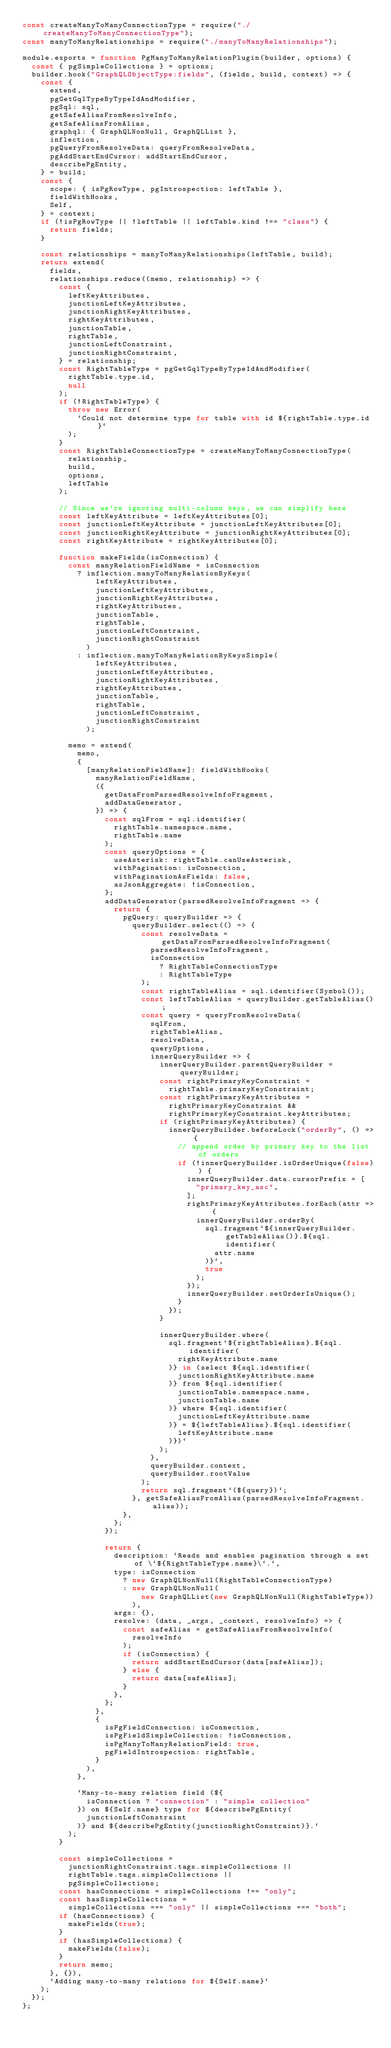<code> <loc_0><loc_0><loc_500><loc_500><_JavaScript_>const createManyToManyConnectionType = require("./createManyToManyConnectionType");
const manyToManyRelationships = require("./manyToManyRelationships");

module.exports = function PgManyToManyRelationPlugin(builder, options) {
  const { pgSimpleCollections } = options;
  builder.hook("GraphQLObjectType:fields", (fields, build, context) => {
    const {
      extend,
      pgGetGqlTypeByTypeIdAndModifier,
      pgSql: sql,
      getSafeAliasFromResolveInfo,
      getSafeAliasFromAlias,
      graphql: { GraphQLNonNull, GraphQLList },
      inflection,
      pgQueryFromResolveData: queryFromResolveData,
      pgAddStartEndCursor: addStartEndCursor,
      describePgEntity,
    } = build;
    const {
      scope: { isPgRowType, pgIntrospection: leftTable },
      fieldWithHooks,
      Self,
    } = context;
    if (!isPgRowType || !leftTable || leftTable.kind !== "class") {
      return fields;
    }

    const relationships = manyToManyRelationships(leftTable, build);
    return extend(
      fields,
      relationships.reduce((memo, relationship) => {
        const {
          leftKeyAttributes,
          junctionLeftKeyAttributes,
          junctionRightKeyAttributes,
          rightKeyAttributes,
          junctionTable,
          rightTable,
          junctionLeftConstraint,
          junctionRightConstraint,
        } = relationship;
        const RightTableType = pgGetGqlTypeByTypeIdAndModifier(
          rightTable.type.id,
          null
        );
        if (!RightTableType) {
          throw new Error(
            `Could not determine type for table with id ${rightTable.type.id}`
          );
        }
        const RightTableConnectionType = createManyToManyConnectionType(
          relationship,
          build,
          options,
          leftTable
        );

        // Since we're ignoring multi-column keys, we can simplify here
        const leftKeyAttribute = leftKeyAttributes[0];
        const junctionLeftKeyAttribute = junctionLeftKeyAttributes[0];
        const junctionRightKeyAttribute = junctionRightKeyAttributes[0];
        const rightKeyAttribute = rightKeyAttributes[0];

        function makeFields(isConnection) {
          const manyRelationFieldName = isConnection
            ? inflection.manyToManyRelationByKeys(
                leftKeyAttributes,
                junctionLeftKeyAttributes,
                junctionRightKeyAttributes,
                rightKeyAttributes,
                junctionTable,
                rightTable,
                junctionLeftConstraint,
                junctionRightConstraint
              )
            : inflection.manyToManyRelationByKeysSimple(
                leftKeyAttributes,
                junctionLeftKeyAttributes,
                junctionRightKeyAttributes,
                rightKeyAttributes,
                junctionTable,
                rightTable,
                junctionLeftConstraint,
                junctionRightConstraint
              );

          memo = extend(
            memo,
            {
              [manyRelationFieldName]: fieldWithHooks(
                manyRelationFieldName,
                ({
                  getDataFromParsedResolveInfoFragment,
                  addDataGenerator,
                }) => {
                  const sqlFrom = sql.identifier(
                    rightTable.namespace.name,
                    rightTable.name
                  );
                  const queryOptions = {
                    useAsterisk: rightTable.canUseAsterisk,
                    withPagination: isConnection,
                    withPaginationAsFields: false,
                    asJsonAggregate: !isConnection,
                  };
                  addDataGenerator(parsedResolveInfoFragment => {
                    return {
                      pgQuery: queryBuilder => {
                        queryBuilder.select(() => {
                          const resolveData = getDataFromParsedResolveInfoFragment(
                            parsedResolveInfoFragment,
                            isConnection
                              ? RightTableConnectionType
                              : RightTableType
                          );
                          const rightTableAlias = sql.identifier(Symbol());
                          const leftTableAlias = queryBuilder.getTableAlias();
                          const query = queryFromResolveData(
                            sqlFrom,
                            rightTableAlias,
                            resolveData,
                            queryOptions,
                            innerQueryBuilder => {
                              innerQueryBuilder.parentQueryBuilder = queryBuilder;
                              const rightPrimaryKeyConstraint =
                                rightTable.primaryKeyConstraint;
                              const rightPrimaryKeyAttributes =
                                rightPrimaryKeyConstraint &&
                                rightPrimaryKeyConstraint.keyAttributes;
                              if (rightPrimaryKeyAttributes) {
                                innerQueryBuilder.beforeLock("orderBy", () => {
                                  // append order by primary key to the list of orders
                                  if (!innerQueryBuilder.isOrderUnique(false)) {
                                    innerQueryBuilder.data.cursorPrefix = [
                                      "primary_key_asc",
                                    ];
                                    rightPrimaryKeyAttributes.forEach(attr => {
                                      innerQueryBuilder.orderBy(
                                        sql.fragment`${innerQueryBuilder.getTableAlias()}.${sql.identifier(
                                          attr.name
                                        )}`,
                                        true
                                      );
                                    });
                                    innerQueryBuilder.setOrderIsUnique();
                                  }
                                });
                              }

                              innerQueryBuilder.where(
                                sql.fragment`${rightTableAlias}.${sql.identifier(
                                  rightKeyAttribute.name
                                )} in (select ${sql.identifier(
                                  junctionRightKeyAttribute.name
                                )} from ${sql.identifier(
                                  junctionTable.namespace.name,
                                  junctionTable.name
                                )} where ${sql.identifier(
                                  junctionLeftKeyAttribute.name
                                )} = ${leftTableAlias}.${sql.identifier(
                                  leftKeyAttribute.name
                                )})`
                              );
                            },
                            queryBuilder.context,
                            queryBuilder.rootValue
                          );
                          return sql.fragment`(${query})`;
                        }, getSafeAliasFromAlias(parsedResolveInfoFragment.alias));
                      },
                    };
                  });

                  return {
                    description: `Reads and enables pagination through a set of \`${RightTableType.name}\`.`,
                    type: isConnection
                      ? new GraphQLNonNull(RightTableConnectionType)
                      : new GraphQLNonNull(
                          new GraphQLList(new GraphQLNonNull(RightTableType))
                        ),
                    args: {},
                    resolve: (data, _args, _context, resolveInfo) => {
                      const safeAlias = getSafeAliasFromResolveInfo(
                        resolveInfo
                      );
                      if (isConnection) {
                        return addStartEndCursor(data[safeAlias]);
                      } else {
                        return data[safeAlias];
                      }
                    },
                  };
                },
                {
                  isPgFieldConnection: isConnection,
                  isPgFieldSimpleCollection: !isConnection,
                  isPgManyToManyRelationField: true,
                  pgFieldIntrospection: rightTable,
                }
              ),
            },

            `Many-to-many relation field (${
              isConnection ? "connection" : "simple collection"
            }) on ${Self.name} type for ${describePgEntity(
              junctionLeftConstraint
            )} and ${describePgEntity(junctionRightConstraint)}.`
          );
        }

        const simpleCollections =
          junctionRightConstraint.tags.simpleCollections ||
          rightTable.tags.simpleCollections ||
          pgSimpleCollections;
        const hasConnections = simpleCollections !== "only";
        const hasSimpleCollections =
          simpleCollections === "only" || simpleCollections === "both";
        if (hasConnections) {
          makeFields(true);
        }
        if (hasSimpleCollections) {
          makeFields(false);
        }
        return memo;
      }, {}),
      `Adding many-to-many relations for ${Self.name}`
    );
  });
};
</code> 